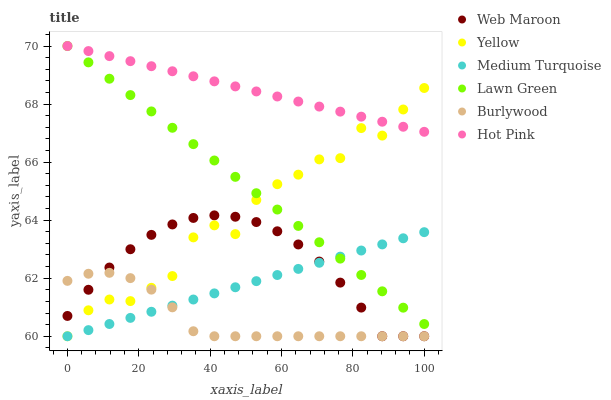Does Burlywood have the minimum area under the curve?
Answer yes or no. Yes. Does Hot Pink have the maximum area under the curve?
Answer yes or no. Yes. Does Hot Pink have the minimum area under the curve?
Answer yes or no. No. Does Burlywood have the maximum area under the curve?
Answer yes or no. No. Is Lawn Green the smoothest?
Answer yes or no. Yes. Is Yellow the roughest?
Answer yes or no. Yes. Is Burlywood the smoothest?
Answer yes or no. No. Is Burlywood the roughest?
Answer yes or no. No. Does Burlywood have the lowest value?
Answer yes or no. Yes. Does Hot Pink have the lowest value?
Answer yes or no. No. Does Hot Pink have the highest value?
Answer yes or no. Yes. Does Burlywood have the highest value?
Answer yes or no. No. Is Medium Turquoise less than Hot Pink?
Answer yes or no. Yes. Is Hot Pink greater than Web Maroon?
Answer yes or no. Yes. Does Burlywood intersect Yellow?
Answer yes or no. Yes. Is Burlywood less than Yellow?
Answer yes or no. No. Is Burlywood greater than Yellow?
Answer yes or no. No. Does Medium Turquoise intersect Hot Pink?
Answer yes or no. No. 